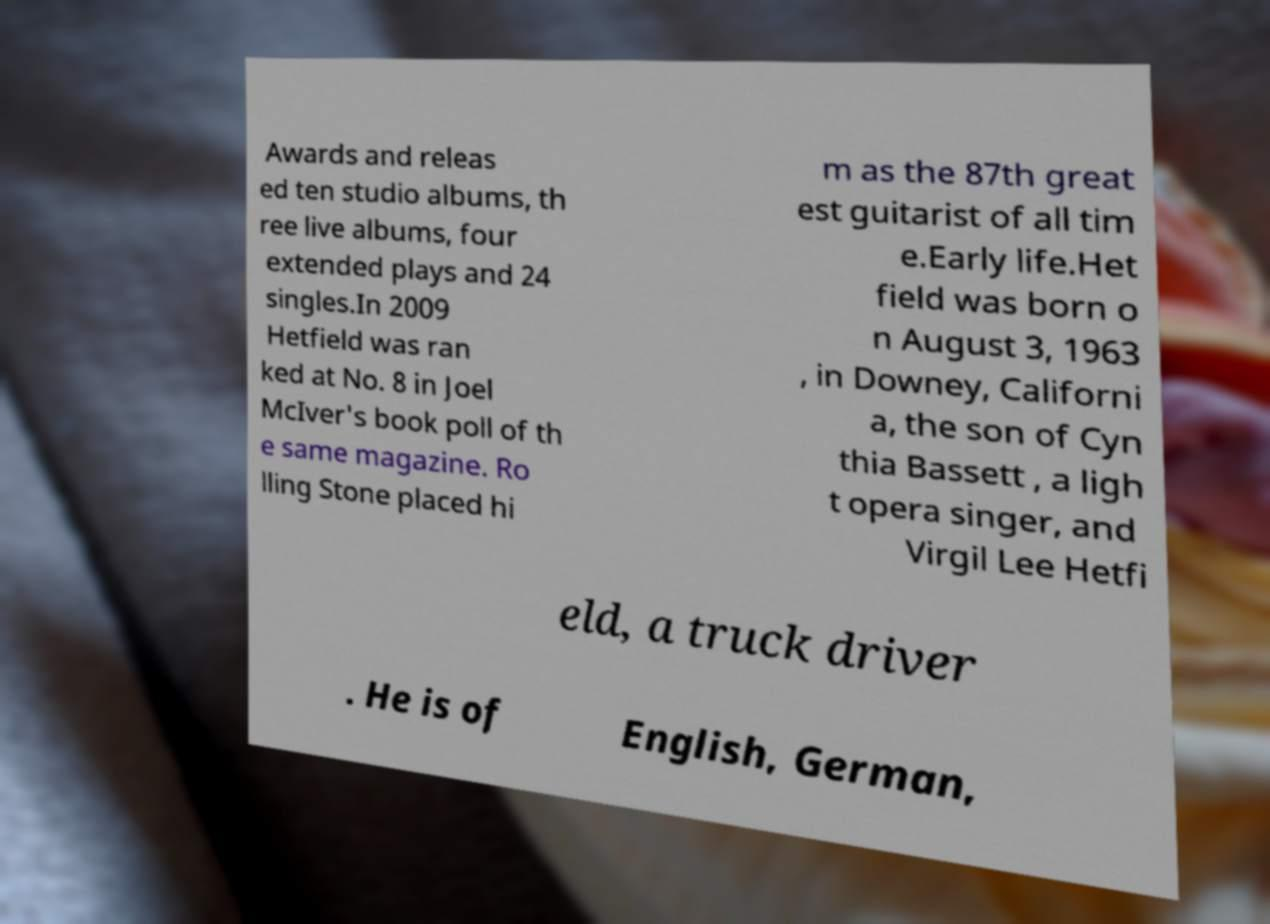Please identify and transcribe the text found in this image. Awards and releas ed ten studio albums, th ree live albums, four extended plays and 24 singles.In 2009 Hetfield was ran ked at No. 8 in Joel McIver's book poll of th e same magazine. Ro lling Stone placed hi m as the 87th great est guitarist of all tim e.Early life.Het field was born o n August 3, 1963 , in Downey, Californi a, the son of Cyn thia Bassett , a ligh t opera singer, and Virgil Lee Hetfi eld, a truck driver . He is of English, German, 